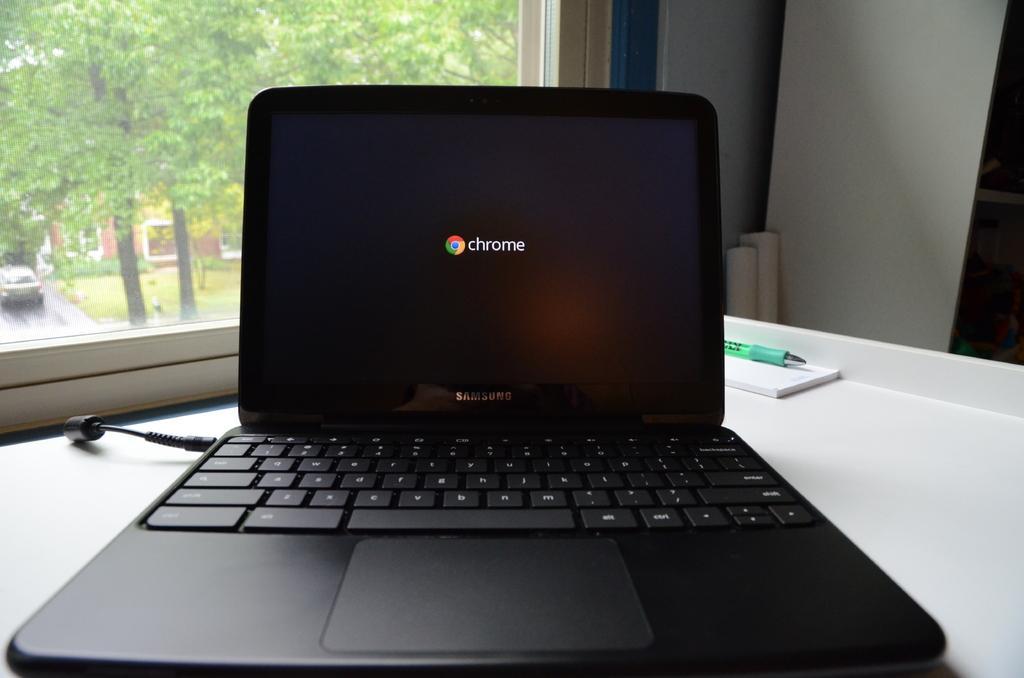Describe this image in one or two sentences. In this picture we can see a laptop, pen, window and from window we can see trees and a vehicle on the road. 